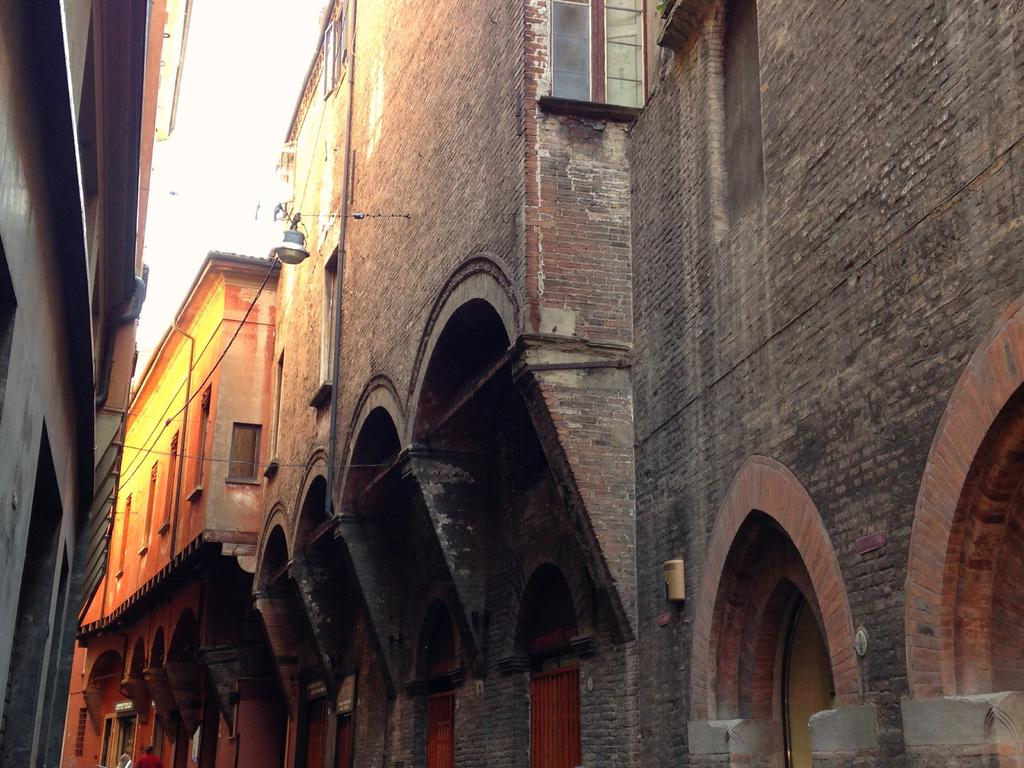What types of structures can be seen in the image? There are different types of buildings in the image. How many doors are present on each building? Each building has multiple doors. What can be seen in the background of the image? There is a sky visible in the background of the image. What type of fear is depicted in the image? There is no fear depicted in the image; it features different types of buildings with multiple doors and a sky in the background. 